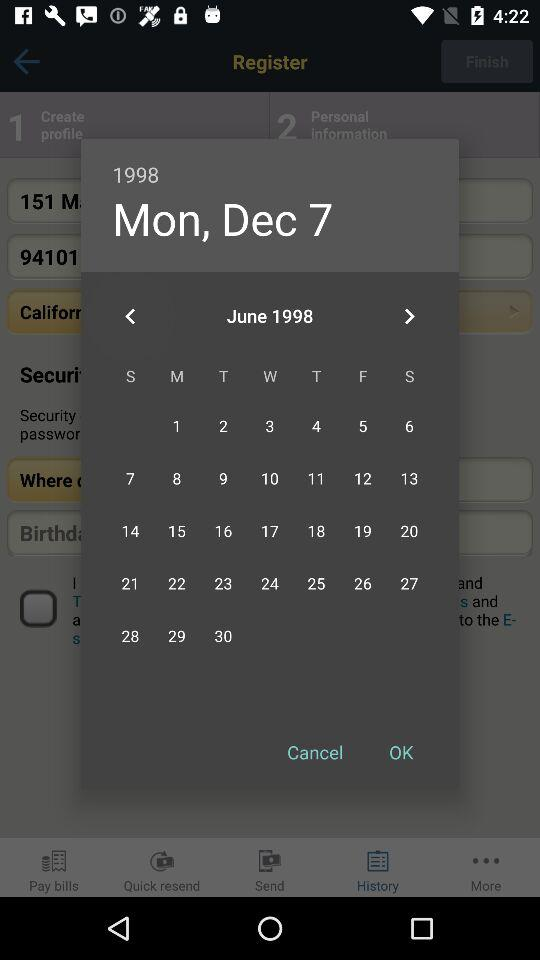What is the selected year? The year is 1998. 